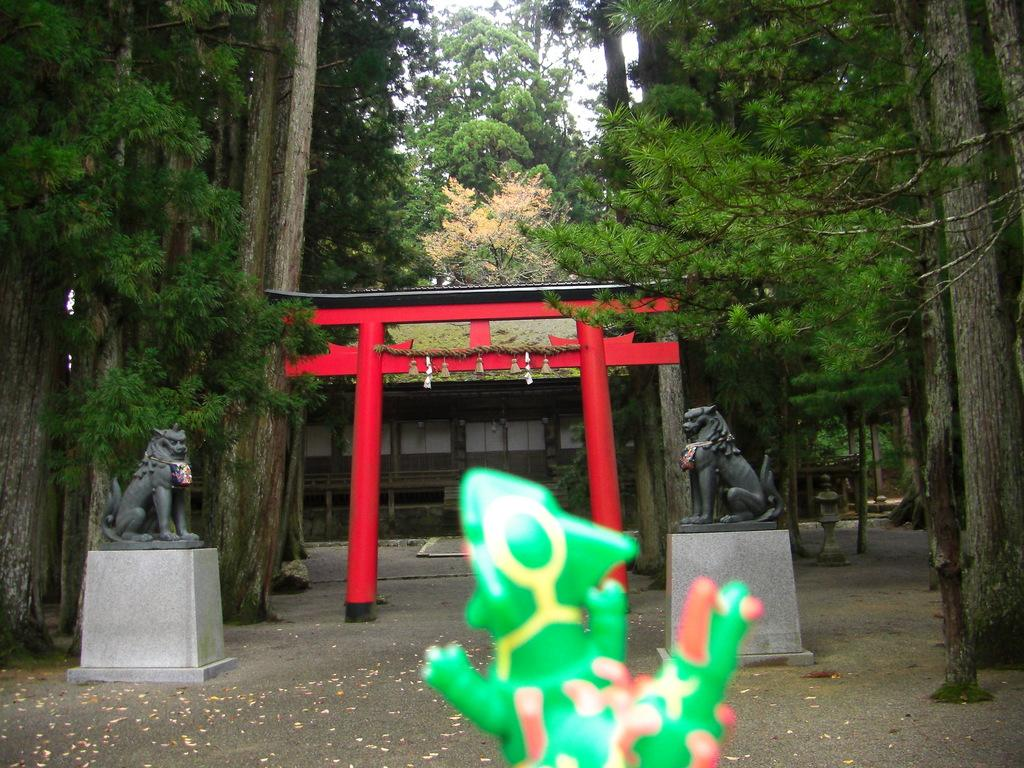What object can be seen in the foreground of the image? There is a toy in the image. What can be seen in the background of the image? There are statues, an arch, a shed, and trees in the background of the image. What structures are visible in the image? Poles are visible in the image. What is at the bottom of the image? There is a road at the bottom of the image. What type of plants are being used to create the paste in the image? There is no mention of plants, paste, or any activity involving plants in the image. 